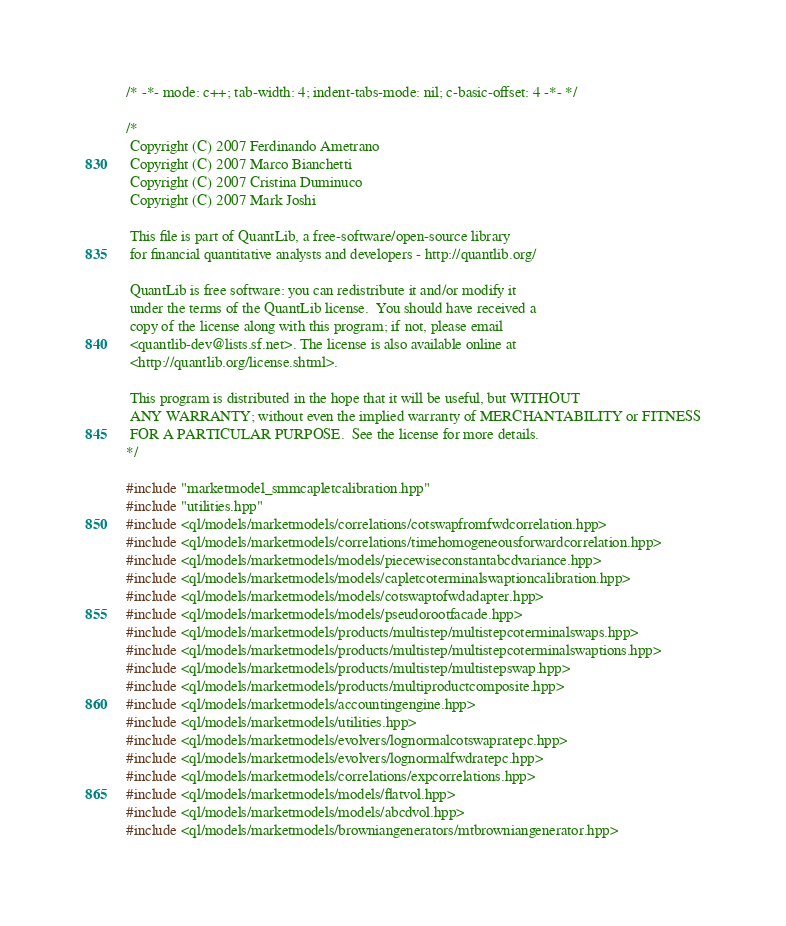Convert code to text. <code><loc_0><loc_0><loc_500><loc_500><_C++_>/* -*- mode: c++; tab-width: 4; indent-tabs-mode: nil; c-basic-offset: 4 -*- */

/*
 Copyright (C) 2007 Ferdinando Ametrano
 Copyright (C) 2007 Marco Bianchetti
 Copyright (C) 2007 Cristina Duminuco
 Copyright (C) 2007 Mark Joshi

 This file is part of QuantLib, a free-software/open-source library
 for financial quantitative analysts and developers - http://quantlib.org/

 QuantLib is free software: you can redistribute it and/or modify it
 under the terms of the QuantLib license.  You should have received a
 copy of the license along with this program; if not, please email
 <quantlib-dev@lists.sf.net>. The license is also available online at
 <http://quantlib.org/license.shtml>.

 This program is distributed in the hope that it will be useful, but WITHOUT
 ANY WARRANTY; without even the implied warranty of MERCHANTABILITY or FITNESS
 FOR A PARTICULAR PURPOSE.  See the license for more details.
*/

#include "marketmodel_smmcapletcalibration.hpp"
#include "utilities.hpp"
#include <ql/models/marketmodels/correlations/cotswapfromfwdcorrelation.hpp>
#include <ql/models/marketmodels/correlations/timehomogeneousforwardcorrelation.hpp>
#include <ql/models/marketmodels/models/piecewiseconstantabcdvariance.hpp>
#include <ql/models/marketmodels/models/capletcoterminalswaptioncalibration.hpp>
#include <ql/models/marketmodels/models/cotswaptofwdadapter.hpp>
#include <ql/models/marketmodels/models/pseudorootfacade.hpp>
#include <ql/models/marketmodels/products/multistep/multistepcoterminalswaps.hpp>
#include <ql/models/marketmodels/products/multistep/multistepcoterminalswaptions.hpp>
#include <ql/models/marketmodels/products/multistep/multistepswap.hpp>
#include <ql/models/marketmodels/products/multiproductcomposite.hpp>
#include <ql/models/marketmodels/accountingengine.hpp>
#include <ql/models/marketmodels/utilities.hpp>
#include <ql/models/marketmodels/evolvers/lognormalcotswapratepc.hpp>
#include <ql/models/marketmodels/evolvers/lognormalfwdratepc.hpp>
#include <ql/models/marketmodels/correlations/expcorrelations.hpp>
#include <ql/models/marketmodels/models/flatvol.hpp>
#include <ql/models/marketmodels/models/abcdvol.hpp>
#include <ql/models/marketmodels/browniangenerators/mtbrowniangenerator.hpp></code> 